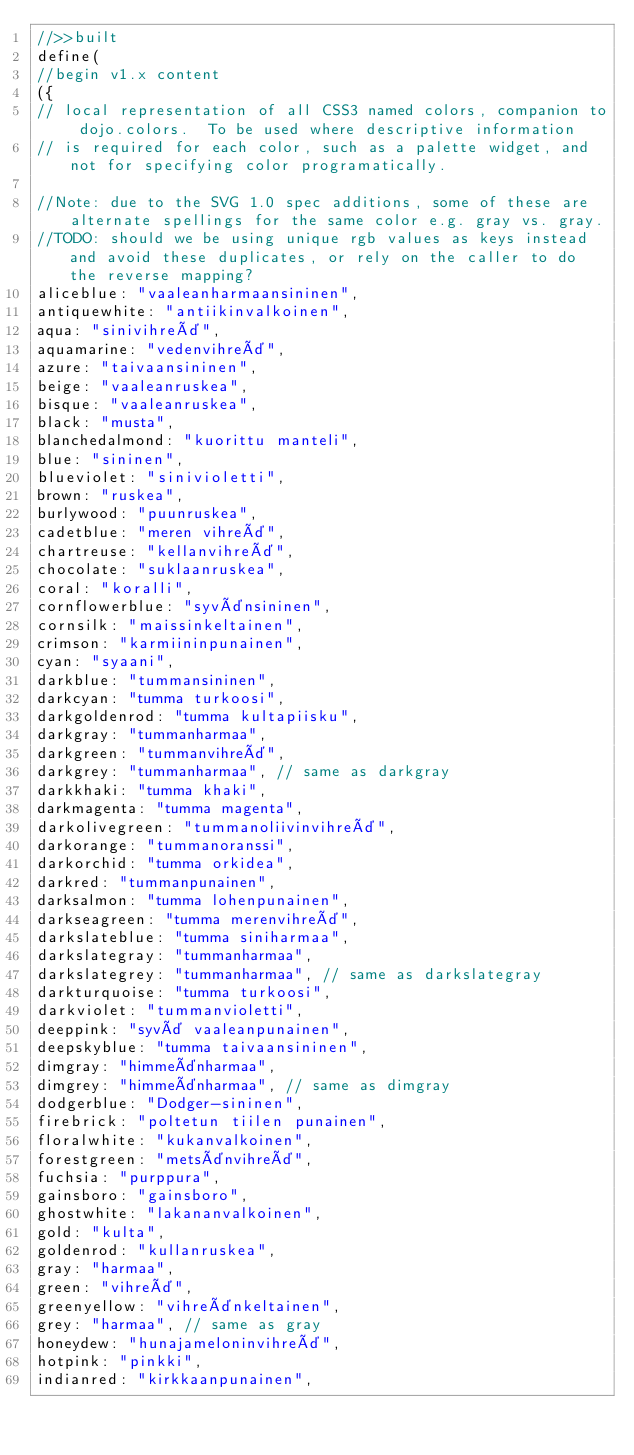Convert code to text. <code><loc_0><loc_0><loc_500><loc_500><_JavaScript_>//>>built
define(
//begin v1.x content
({
// local representation of all CSS3 named colors, companion to dojo.colors.  To be used where descriptive information
// is required for each color, such as a palette widget, and not for specifying color programatically.

//Note: due to the SVG 1.0 spec additions, some of these are alternate spellings for the same color e.g. gray vs. gray.
//TODO: should we be using unique rgb values as keys instead and avoid these duplicates, or rely on the caller to do the reverse mapping?
aliceblue: "vaaleanharmaansininen",
antiquewhite: "antiikinvalkoinen",
aqua: "sinivihreä",
aquamarine: "vedenvihreä",
azure: "taivaansininen",
beige: "vaaleanruskea",
bisque: "vaaleanruskea",
black: "musta",
blanchedalmond: "kuorittu manteli",
blue: "sininen",
blueviolet: "sinivioletti",
brown: "ruskea",
burlywood: "puunruskea",
cadetblue: "meren vihreä",
chartreuse: "kellanvihreä",
chocolate: "suklaanruskea",
coral: "koralli",
cornflowerblue: "syvänsininen",
cornsilk: "maissinkeltainen",
crimson: "karmiininpunainen",
cyan: "syaani",
darkblue: "tummansininen",
darkcyan: "tumma turkoosi",
darkgoldenrod: "tumma kultapiisku",
darkgray: "tummanharmaa",
darkgreen: "tummanvihreä",
darkgrey: "tummanharmaa", // same as darkgray
darkkhaki: "tumma khaki",
darkmagenta: "tumma magenta",
darkolivegreen: "tummanoliivinvihreä",
darkorange: "tummanoranssi",
darkorchid: "tumma orkidea",
darkred: "tummanpunainen",
darksalmon: "tumma lohenpunainen",
darkseagreen: "tumma merenvihreä",
darkslateblue: "tumma siniharmaa",
darkslategray: "tummanharmaa",
darkslategrey: "tummanharmaa", // same as darkslategray
darkturquoise: "tumma turkoosi",
darkviolet: "tummanvioletti",
deeppink: "syvä vaaleanpunainen",
deepskyblue: "tumma taivaansininen",
dimgray: "himmeänharmaa",
dimgrey: "himmeänharmaa", // same as dimgray
dodgerblue: "Dodger-sininen",
firebrick: "poltetun tiilen punainen",
floralwhite: "kukanvalkoinen",
forestgreen: "metsänvihreä",
fuchsia: "purppura",
gainsboro: "gainsboro",
ghostwhite: "lakananvalkoinen",
gold: "kulta",
goldenrod: "kullanruskea",
gray: "harmaa",
green: "vihreä",
greenyellow: "vihreänkeltainen",
grey: "harmaa", // same as gray
honeydew: "hunajameloninvihreä",
hotpink: "pinkki",
indianred: "kirkkaanpunainen",</code> 